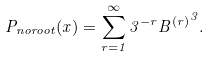Convert formula to latex. <formula><loc_0><loc_0><loc_500><loc_500>P _ { n o r o o t } ( x ) = \sum _ { r = 1 } ^ { \infty } 3 ^ { - r } { B ^ { ( r ) } } ^ { 3 } .</formula> 